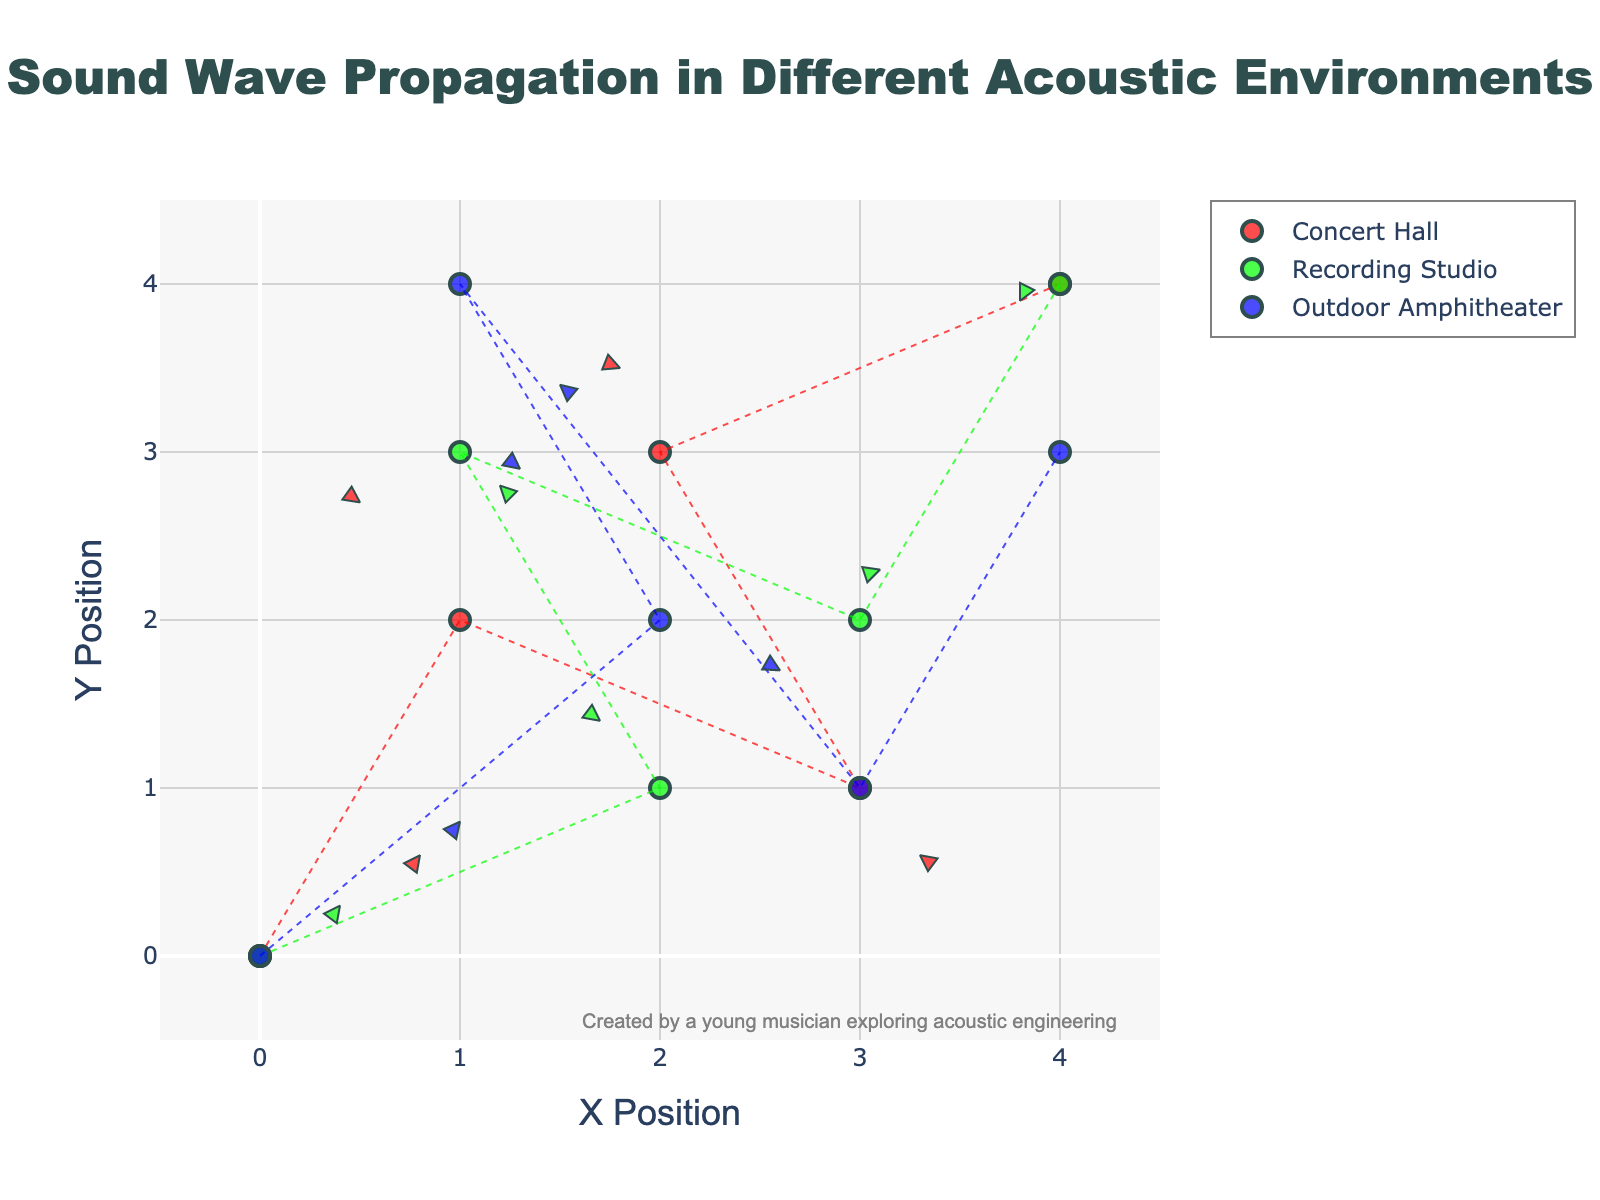What is the title of the figure? The title of the figure is located at the top center and reads "Sound Wave Propagation in Different Acoustic Environments."
Answer: Sound Wave Propagation in Different Acoustic Environments Which environment shows the largest horizontal component of the wave propagation vectors? Look for the environment with the longest arrow pointing horizontally. The longest horizontal vector is in the "Outdoor Amphitheater" at (0,0) with a horizontal component of 1.0.
Answer: Outdoor Amphitheater How many data points are there in the Recording Studio environment? Count the number of markers specific to the Recording Studio environment. Each environment has 5 data points, indicated by green markers.
Answer: 5 What's the average vertical component of the vectors in the Concert Hall? The vertical components in the Concert Hall are 0.6, 0.7, -0.4, 0.5, and 0.2. Sum these values (0.6 + 0.7 - 0.4 + 0.5 + 0.2 = 1.6) and divide by the number of vectors, which is 5. So, 1.6/5 = 0.32.
Answer: 0.32 Which environment has a vector component with the largest negative vertical value? Identify the vector with the most significant negative vertical value. In "Outdoor Amphitheater" at (1,4), the vertical component is -0.6, which is the largest negative vertical value.
Answer: Outdoor Amphitheater Where is the longest vector located in the figure? Compare the magnitudes of all vectors using the distances defined by their horizontal and vertical components. The longest vector is in the "Outdoor Amphitheater" at (0,0), with components (1.0, 0.8).
Answer: (0,0) How do the vectors in the Recording Studio environment compare directionally to those in the Concert Hall? Visually inspect the angle and direction of the vectors. Vectors in the Recording Studio have less consistency directionally compared to Concert Hall vectors, which generally point upwards and to the right.
Answer: Less consistent than the Concert Hall Which environment has vectors pointing in mostly upward directions? Identify the dominant direction in each environment. The vectors in a Concert Hall mostly trend upwards.
Answer: Concert Hall What's the average horizontal component of the vectors in the Recording Studio? The horizontal components in the Recording Studio are 0.4, -0.3, 0.2, 0.1, -0.2. Sum them (0.4 -0.3 + 0.2 + 0.1 -0.2 = 0.2) and divide by the number of vectors, which is 5. So, 0.2/5 = 0.04.
Answer: 0.04 